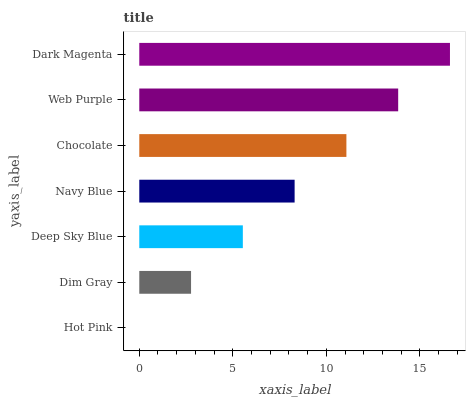Is Hot Pink the minimum?
Answer yes or no. Yes. Is Dark Magenta the maximum?
Answer yes or no. Yes. Is Dim Gray the minimum?
Answer yes or no. No. Is Dim Gray the maximum?
Answer yes or no. No. Is Dim Gray greater than Hot Pink?
Answer yes or no. Yes. Is Hot Pink less than Dim Gray?
Answer yes or no. Yes. Is Hot Pink greater than Dim Gray?
Answer yes or no. No. Is Dim Gray less than Hot Pink?
Answer yes or no. No. Is Navy Blue the high median?
Answer yes or no. Yes. Is Navy Blue the low median?
Answer yes or no. Yes. Is Dim Gray the high median?
Answer yes or no. No. Is Dim Gray the low median?
Answer yes or no. No. 